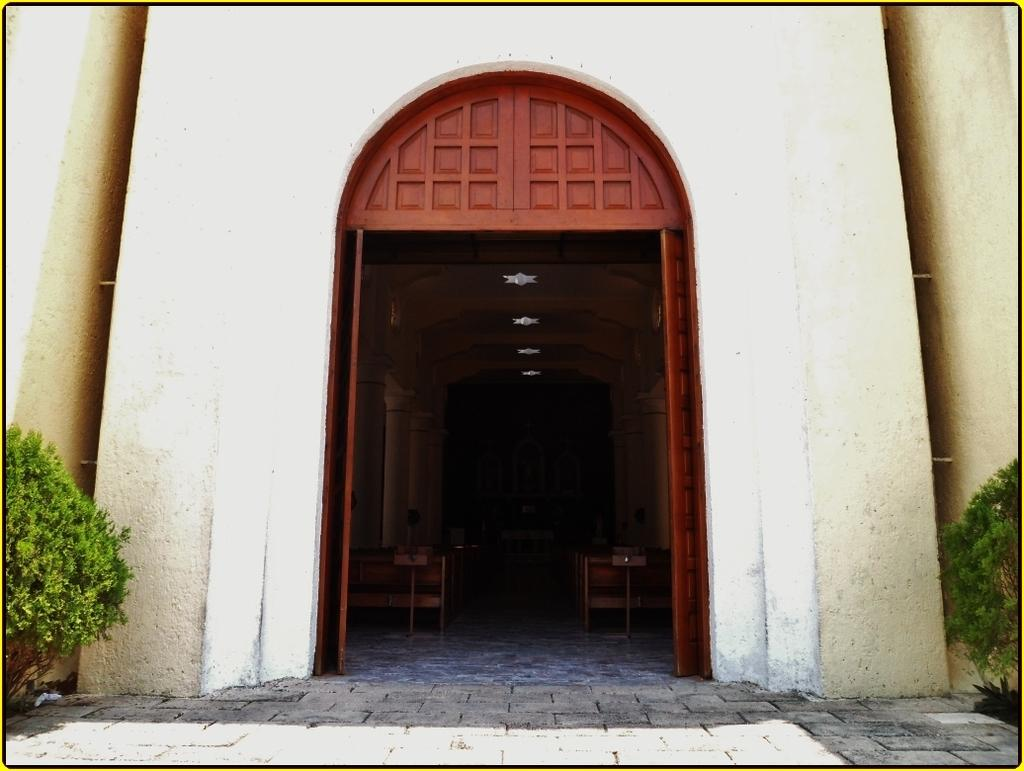What is present on both sides of the image? There are plants on both the left and right sides of the image. What type of structure is visible in the image? There is a wall in the image, and inside the building, there are doors. What type of furniture can be seen inside the building? There are chairs on the floor inside the building. What architectural features are present in the building? There are pillars in the building, and lights are on the ceiling. What type of twig is being used to sew silk onto the needle in the image? There is no twig, silk, or needle present in the image. 